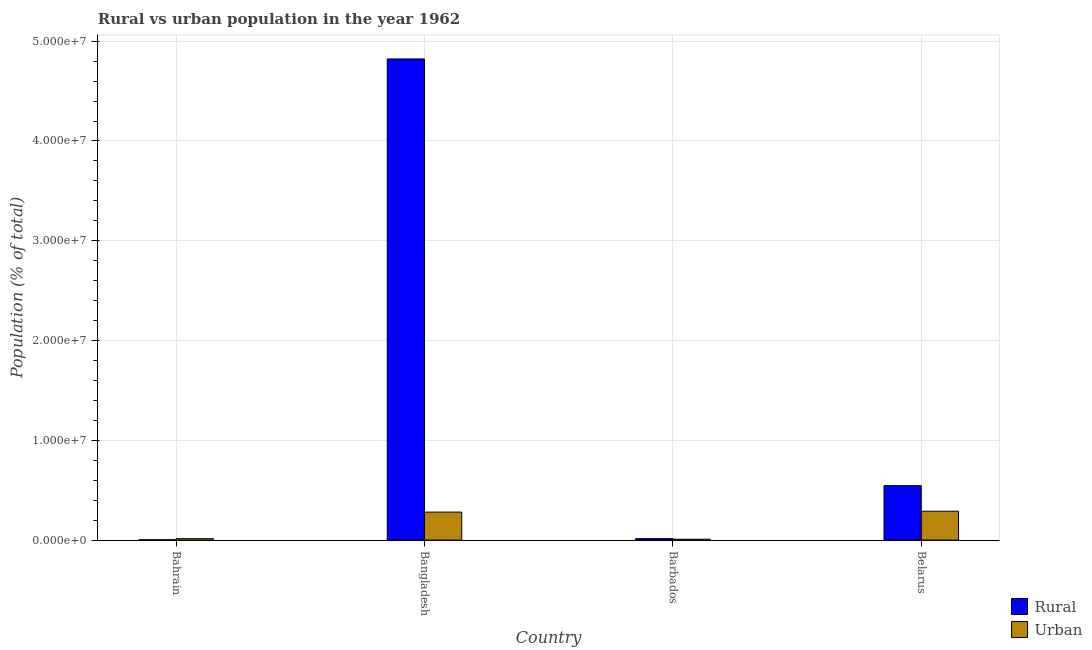How many different coloured bars are there?
Your response must be concise. 2. How many groups of bars are there?
Offer a very short reply. 4. Are the number of bars per tick equal to the number of legend labels?
Offer a very short reply. Yes. How many bars are there on the 4th tick from the left?
Your response must be concise. 2. How many bars are there on the 4th tick from the right?
Ensure brevity in your answer.  2. What is the label of the 1st group of bars from the left?
Your response must be concise. Bahrain. In how many cases, is the number of bars for a given country not equal to the number of legend labels?
Your response must be concise. 0. What is the rural population density in Belarus?
Your response must be concise. 5.46e+06. Across all countries, what is the maximum rural population density?
Give a very brief answer. 4.82e+07. Across all countries, what is the minimum urban population density?
Offer a very short reply. 8.59e+04. In which country was the rural population density minimum?
Your answer should be very brief. Bahrain. What is the total rural population density in the graph?
Offer a very short reply. 5.39e+07. What is the difference between the rural population density in Bangladesh and that in Barbados?
Your answer should be compact. 4.81e+07. What is the difference between the rural population density in Bahrain and the urban population density in Barbados?
Give a very brief answer. -5.53e+04. What is the average urban population density per country?
Provide a short and direct response. 1.48e+06. What is the difference between the rural population density and urban population density in Barbados?
Offer a terse response. 6.08e+04. What is the ratio of the rural population density in Bangladesh to that in Barbados?
Your response must be concise. 328.71. What is the difference between the highest and the second highest rural population density?
Your answer should be compact. 4.28e+07. What is the difference between the highest and the lowest rural population density?
Your answer should be very brief. 4.82e+07. Is the sum of the urban population density in Bahrain and Bangladesh greater than the maximum rural population density across all countries?
Offer a terse response. No. What does the 2nd bar from the left in Bangladesh represents?
Provide a short and direct response. Urban. What does the 1st bar from the right in Bangladesh represents?
Provide a short and direct response. Urban. How many countries are there in the graph?
Provide a succinct answer. 4. What is the difference between two consecutive major ticks on the Y-axis?
Offer a very short reply. 1.00e+07. Are the values on the major ticks of Y-axis written in scientific E-notation?
Make the answer very short. Yes. Where does the legend appear in the graph?
Give a very brief answer. Bottom right. How are the legend labels stacked?
Your answer should be very brief. Vertical. What is the title of the graph?
Make the answer very short. Rural vs urban population in the year 1962. Does "US$" appear as one of the legend labels in the graph?
Provide a short and direct response. No. What is the label or title of the X-axis?
Give a very brief answer. Country. What is the label or title of the Y-axis?
Provide a short and direct response. Population (% of total). What is the Population (% of total) of Rural in Bahrain?
Ensure brevity in your answer.  3.05e+04. What is the Population (% of total) of Urban in Bahrain?
Offer a very short reply. 1.43e+05. What is the Population (% of total) in Rural in Bangladesh?
Provide a succinct answer. 4.82e+07. What is the Population (% of total) in Urban in Bangladesh?
Your response must be concise. 2.81e+06. What is the Population (% of total) of Rural in Barbados?
Provide a succinct answer. 1.47e+05. What is the Population (% of total) of Urban in Barbados?
Your answer should be very brief. 8.59e+04. What is the Population (% of total) of Rural in Belarus?
Make the answer very short. 5.46e+06. What is the Population (% of total) in Urban in Belarus?
Offer a terse response. 2.90e+06. Across all countries, what is the maximum Population (% of total) of Rural?
Provide a short and direct response. 4.82e+07. Across all countries, what is the maximum Population (% of total) in Urban?
Offer a terse response. 2.90e+06. Across all countries, what is the minimum Population (% of total) in Rural?
Keep it short and to the point. 3.05e+04. Across all countries, what is the minimum Population (% of total) of Urban?
Your response must be concise. 8.59e+04. What is the total Population (% of total) in Rural in the graph?
Your response must be concise. 5.39e+07. What is the total Population (% of total) of Urban in the graph?
Offer a very short reply. 5.93e+06. What is the difference between the Population (% of total) of Rural in Bahrain and that in Bangladesh?
Offer a very short reply. -4.82e+07. What is the difference between the Population (% of total) of Urban in Bahrain and that in Bangladesh?
Your response must be concise. -2.66e+06. What is the difference between the Population (% of total) in Rural in Bahrain and that in Barbados?
Offer a terse response. -1.16e+05. What is the difference between the Population (% of total) of Urban in Bahrain and that in Barbados?
Ensure brevity in your answer.  5.67e+04. What is the difference between the Population (% of total) of Rural in Bahrain and that in Belarus?
Make the answer very short. -5.43e+06. What is the difference between the Population (% of total) of Urban in Bahrain and that in Belarus?
Give a very brief answer. -2.75e+06. What is the difference between the Population (% of total) of Rural in Bangladesh and that in Barbados?
Offer a terse response. 4.81e+07. What is the difference between the Population (% of total) in Urban in Bangladesh and that in Barbados?
Your answer should be very brief. 2.72e+06. What is the difference between the Population (% of total) of Rural in Bangladesh and that in Belarus?
Your answer should be very brief. 4.28e+07. What is the difference between the Population (% of total) of Urban in Bangladesh and that in Belarus?
Your answer should be very brief. -8.94e+04. What is the difference between the Population (% of total) in Rural in Barbados and that in Belarus?
Your answer should be very brief. -5.31e+06. What is the difference between the Population (% of total) in Urban in Barbados and that in Belarus?
Your response must be concise. -2.81e+06. What is the difference between the Population (% of total) of Rural in Bahrain and the Population (% of total) of Urban in Bangladesh?
Your answer should be very brief. -2.78e+06. What is the difference between the Population (% of total) in Rural in Bahrain and the Population (% of total) in Urban in Barbados?
Keep it short and to the point. -5.53e+04. What is the difference between the Population (% of total) of Rural in Bahrain and the Population (% of total) of Urban in Belarus?
Make the answer very short. -2.86e+06. What is the difference between the Population (% of total) of Rural in Bangladesh and the Population (% of total) of Urban in Barbados?
Make the answer very short. 4.81e+07. What is the difference between the Population (% of total) in Rural in Bangladesh and the Population (% of total) in Urban in Belarus?
Make the answer very short. 4.53e+07. What is the difference between the Population (% of total) in Rural in Barbados and the Population (% of total) in Urban in Belarus?
Provide a short and direct response. -2.75e+06. What is the average Population (% of total) in Rural per country?
Ensure brevity in your answer.  1.35e+07. What is the average Population (% of total) of Urban per country?
Offer a very short reply. 1.48e+06. What is the difference between the Population (% of total) of Rural and Population (% of total) of Urban in Bahrain?
Your answer should be compact. -1.12e+05. What is the difference between the Population (% of total) of Rural and Population (% of total) of Urban in Bangladesh?
Provide a short and direct response. 4.54e+07. What is the difference between the Population (% of total) of Rural and Population (% of total) of Urban in Barbados?
Make the answer very short. 6.08e+04. What is the difference between the Population (% of total) in Rural and Population (% of total) in Urban in Belarus?
Offer a terse response. 2.56e+06. What is the ratio of the Population (% of total) of Rural in Bahrain to that in Bangladesh?
Keep it short and to the point. 0. What is the ratio of the Population (% of total) in Urban in Bahrain to that in Bangladesh?
Make the answer very short. 0.05. What is the ratio of the Population (% of total) of Rural in Bahrain to that in Barbados?
Your answer should be compact. 0.21. What is the ratio of the Population (% of total) in Urban in Bahrain to that in Barbados?
Give a very brief answer. 1.66. What is the ratio of the Population (% of total) of Rural in Bahrain to that in Belarus?
Provide a succinct answer. 0.01. What is the ratio of the Population (% of total) in Urban in Bahrain to that in Belarus?
Offer a terse response. 0.05. What is the ratio of the Population (% of total) in Rural in Bangladesh to that in Barbados?
Provide a short and direct response. 328.71. What is the ratio of the Population (% of total) in Urban in Bangladesh to that in Barbados?
Ensure brevity in your answer.  32.67. What is the ratio of the Population (% of total) in Rural in Bangladesh to that in Belarus?
Provide a succinct answer. 8.84. What is the ratio of the Population (% of total) of Urban in Bangladesh to that in Belarus?
Provide a short and direct response. 0.97. What is the ratio of the Population (% of total) in Rural in Barbados to that in Belarus?
Provide a succinct answer. 0.03. What is the ratio of the Population (% of total) in Urban in Barbados to that in Belarus?
Provide a succinct answer. 0.03. What is the difference between the highest and the second highest Population (% of total) of Rural?
Ensure brevity in your answer.  4.28e+07. What is the difference between the highest and the second highest Population (% of total) in Urban?
Keep it short and to the point. 8.94e+04. What is the difference between the highest and the lowest Population (% of total) in Rural?
Your answer should be very brief. 4.82e+07. What is the difference between the highest and the lowest Population (% of total) in Urban?
Provide a succinct answer. 2.81e+06. 